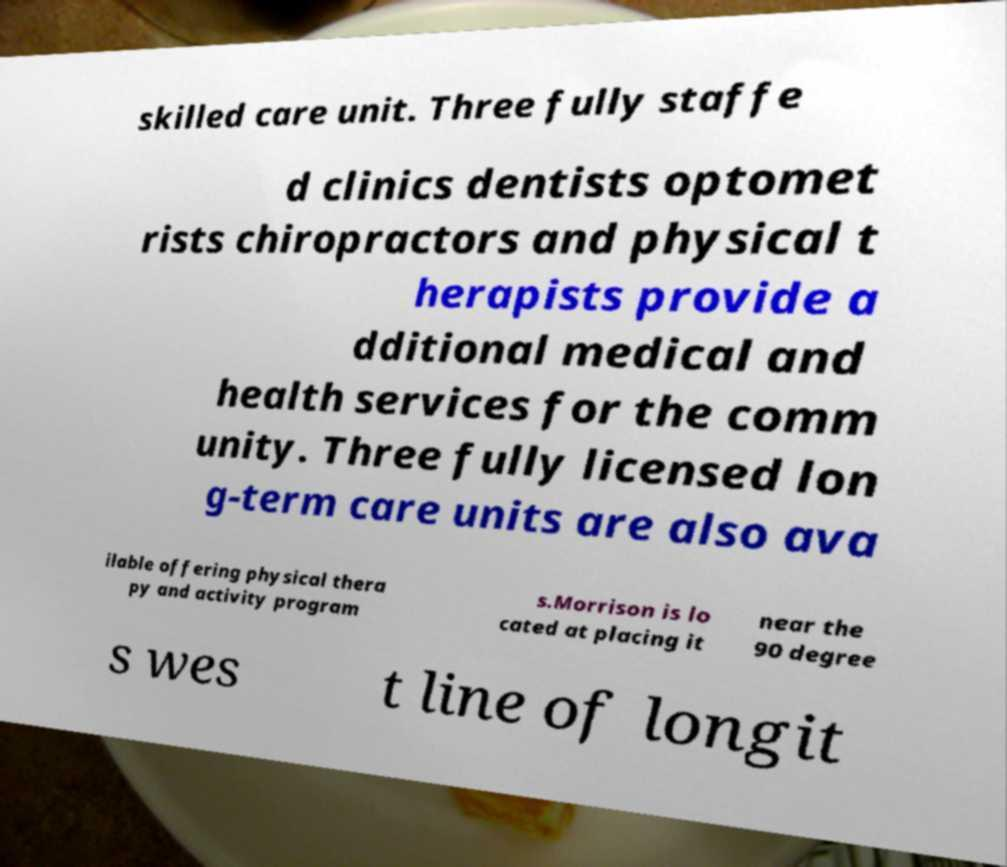There's text embedded in this image that I need extracted. Can you transcribe it verbatim? skilled care unit. Three fully staffe d clinics dentists optomet rists chiropractors and physical t herapists provide a dditional medical and health services for the comm unity. Three fully licensed lon g-term care units are also ava ilable offering physical thera py and activity program s.Morrison is lo cated at placing it near the 90 degree s wes t line of longit 